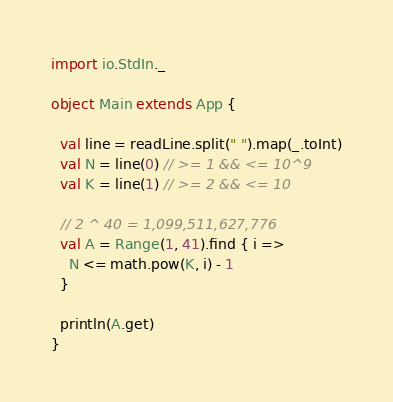<code> <loc_0><loc_0><loc_500><loc_500><_Scala_>import io.StdIn._

object Main extends App {

  val line = readLine.split(" ").map(_.toInt)
  val N = line(0) // >= 1 && <= 10^9
  val K = line(1) // >= 2 && <= 10

  // 2 ^ 40 = 1,099,511,627,776
  val A = Range(1, 41).find { i =>
    N <= math.pow(K, i) - 1
  }

  println(A.get)
}
</code> 